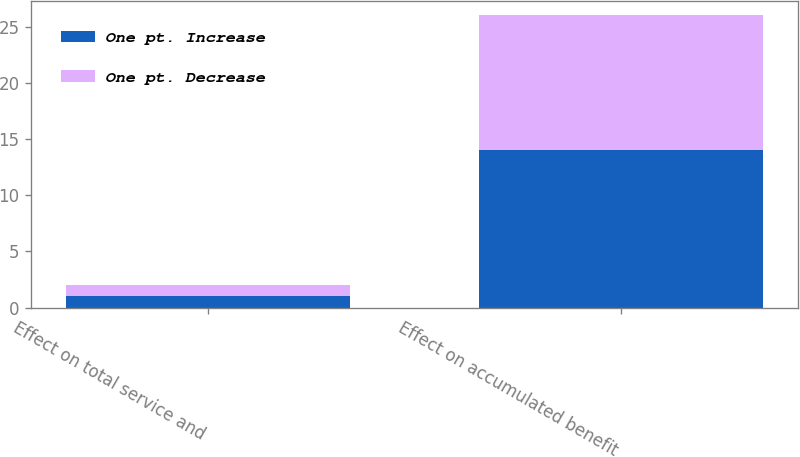Convert chart. <chart><loc_0><loc_0><loc_500><loc_500><stacked_bar_chart><ecel><fcel>Effect on total service and<fcel>Effect on accumulated benefit<nl><fcel>One pt. Increase<fcel>1<fcel>14<nl><fcel>One pt. Decrease<fcel>1<fcel>12<nl></chart> 